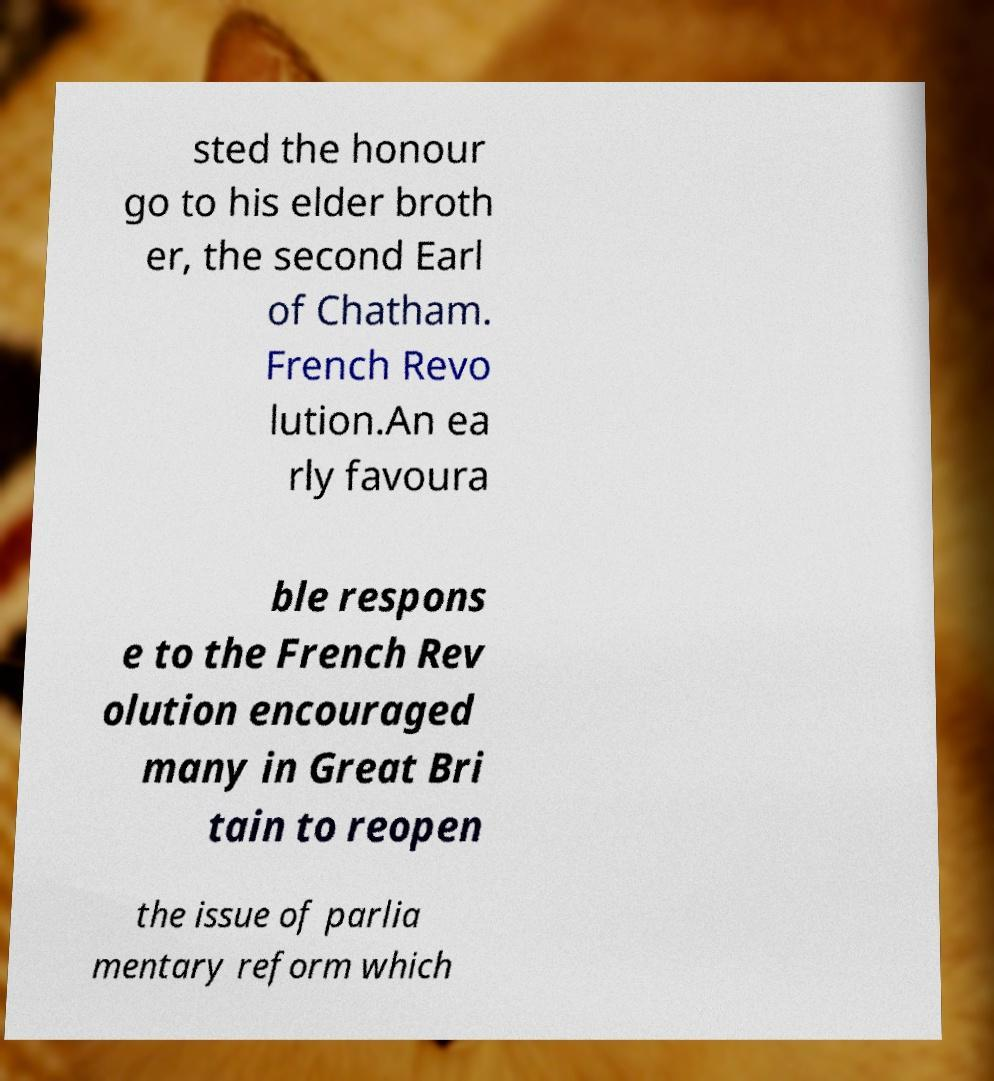Please identify and transcribe the text found in this image. sted the honour go to his elder broth er, the second Earl of Chatham. French Revo lution.An ea rly favoura ble respons e to the French Rev olution encouraged many in Great Bri tain to reopen the issue of parlia mentary reform which 